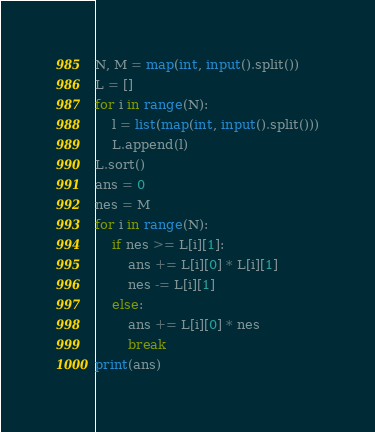<code> <loc_0><loc_0><loc_500><loc_500><_Python_>N, M = map(int, input().split())
L = []
for i in range(N):
    l = list(map(int, input().split()))
    L.append(l)
L.sort()
ans = 0
nes = M
for i in range(N):
    if nes >= L[i][1]:
        ans += L[i][0] * L[i][1]
        nes -= L[i][1]
    else:
        ans += L[i][0] * nes
        break
print(ans)
</code> 